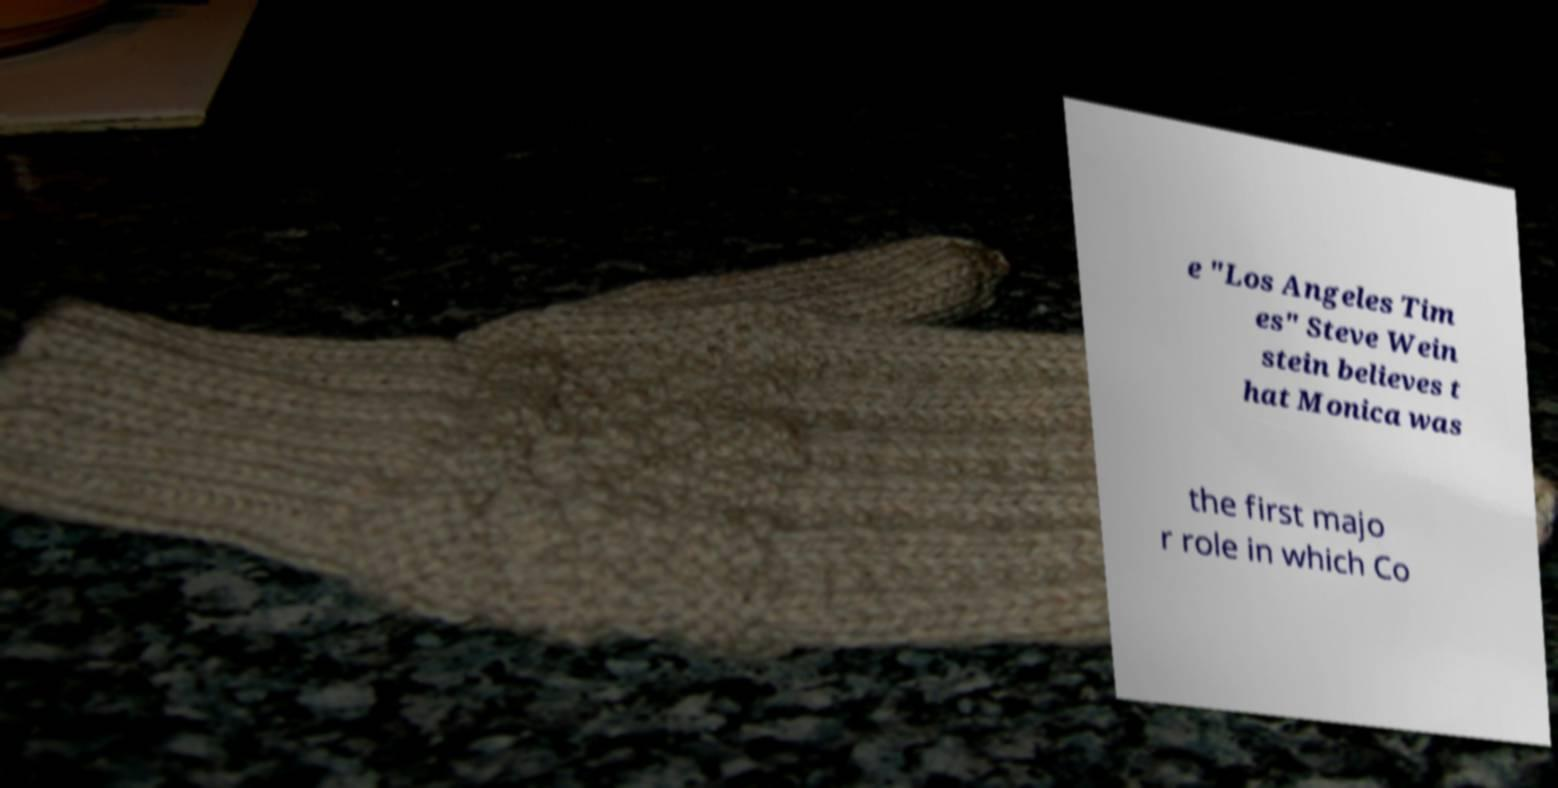Could you extract and type out the text from this image? e "Los Angeles Tim es" Steve Wein stein believes t hat Monica was the first majo r role in which Co 